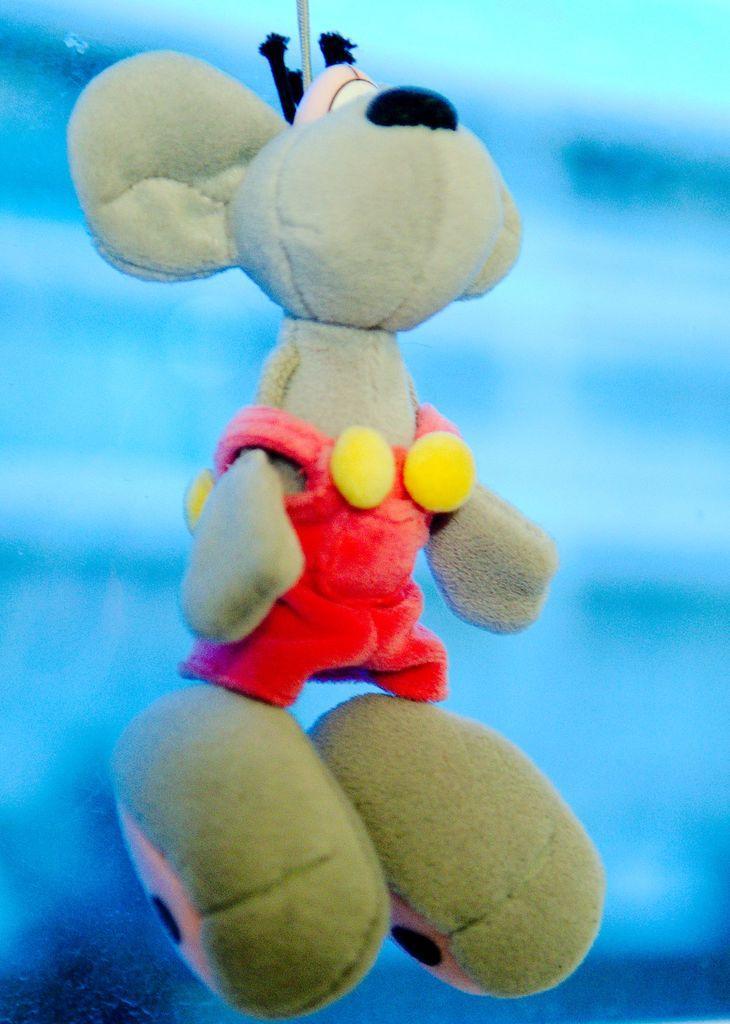How would you summarize this image in a sentence or two? In this picture I can see a toy, and there is blur background. 